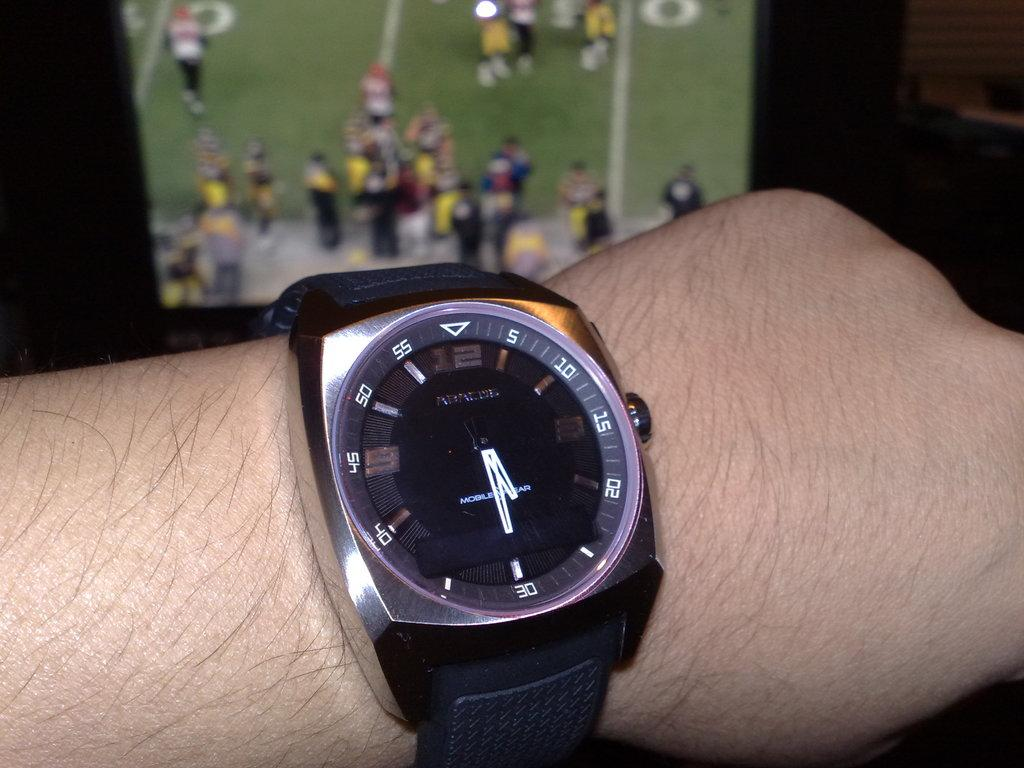<image>
Share a concise interpretation of the image provided. Person wearing a watch that has the hands on the number 30. 